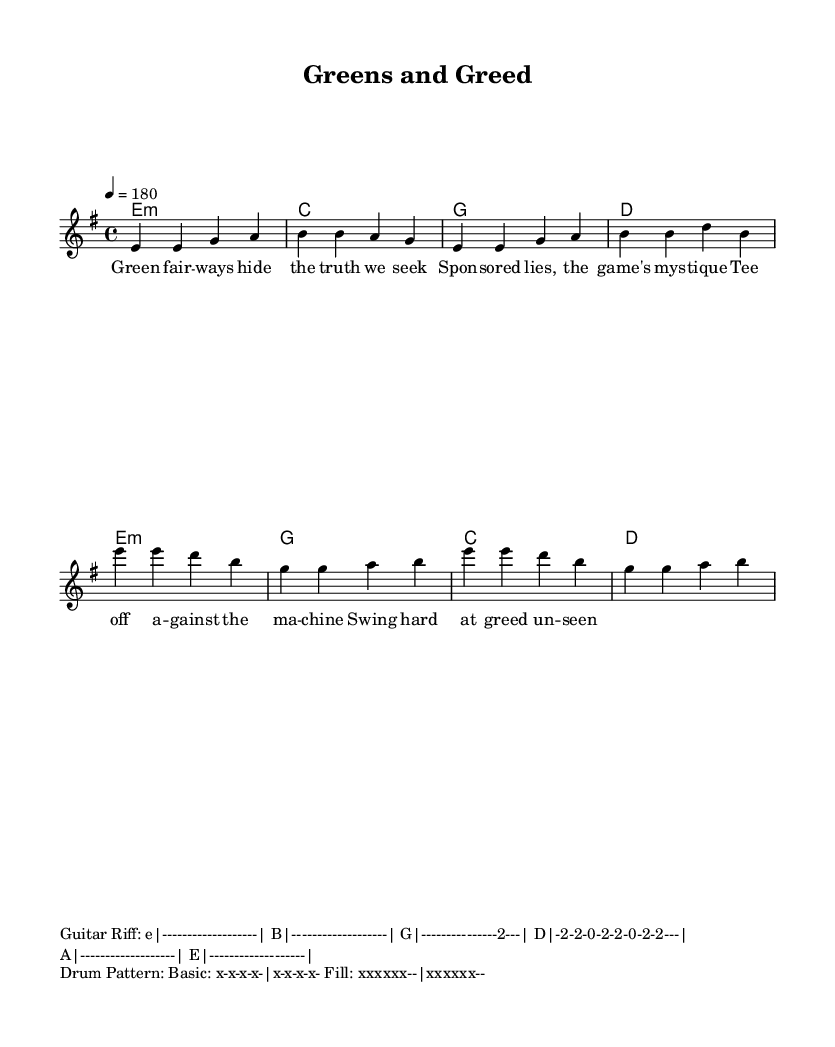What is the key signature of this music? The key signature indicates that there are no sharps or flats present, which defines the key of E minor.
Answer: E minor What is the time signature of this music? The time signature is located at the beginning of the score and indicates that there are four beats in each measure, denoted by 4/4.
Answer: 4/4 What is the tempo marking for this piece? The tempo marking shows the speed at which the music should be played, given as a quarter note equals 180 beats per minute.
Answer: 180 How many measures are in the verse section? By counting the measures listed under the melody for the verse section, there are a total of 4 measures present.
Answer: 4 What is the primary theme of the lyrics in the verse? The lyrics in the verse focus on hypocrisy in sports, highlighting the contrast between reality and the commercialized facade.
Answer: Hypocrisy How do the chords in the chorus differ from the verse? The chords in the chorus change from E minor, C, G, D in the verse to E minor, G, C, D in the chorus, showing a slight shift in the harmonic progression.
Answer: E minor, G, C, D What is the role of the guitar riff in this piece? The guitar riff serves as a rhythmic and melodic foundation, giving the punk song its driving energy, characterized by a simple yet aggressive pattern.
Answer: Driving energy 